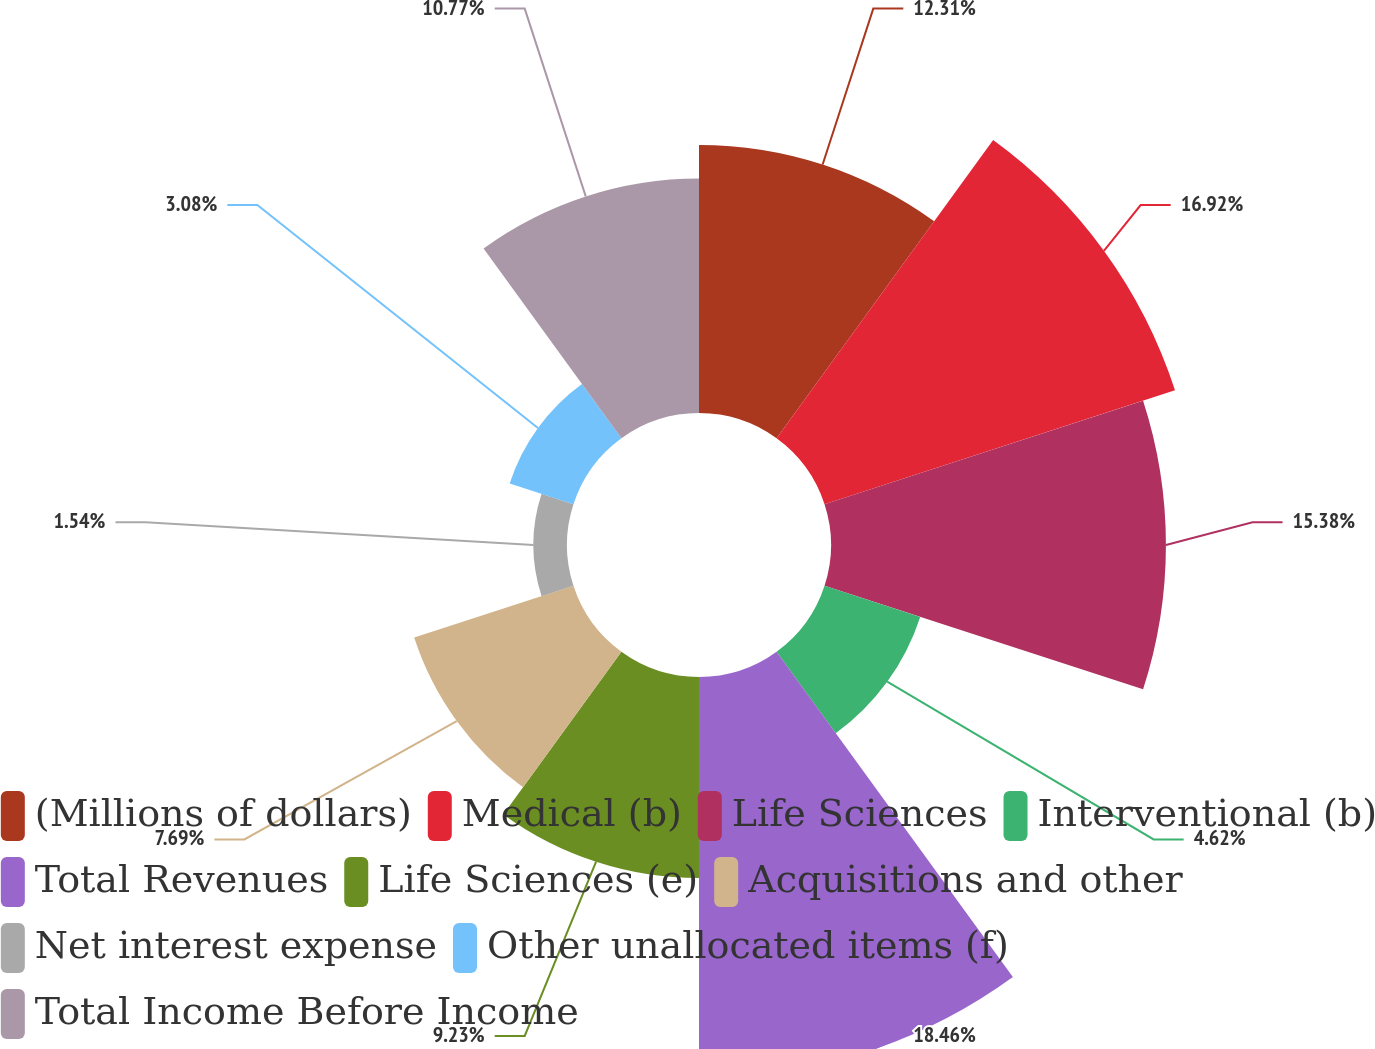Convert chart to OTSL. <chart><loc_0><loc_0><loc_500><loc_500><pie_chart><fcel>(Millions of dollars)<fcel>Medical (b)<fcel>Life Sciences<fcel>Interventional (b)<fcel>Total Revenues<fcel>Life Sciences (e)<fcel>Acquisitions and other<fcel>Net interest expense<fcel>Other unallocated items (f)<fcel>Total Income Before Income<nl><fcel>12.31%<fcel>16.92%<fcel>15.38%<fcel>4.62%<fcel>18.46%<fcel>9.23%<fcel>7.69%<fcel>1.54%<fcel>3.08%<fcel>10.77%<nl></chart> 